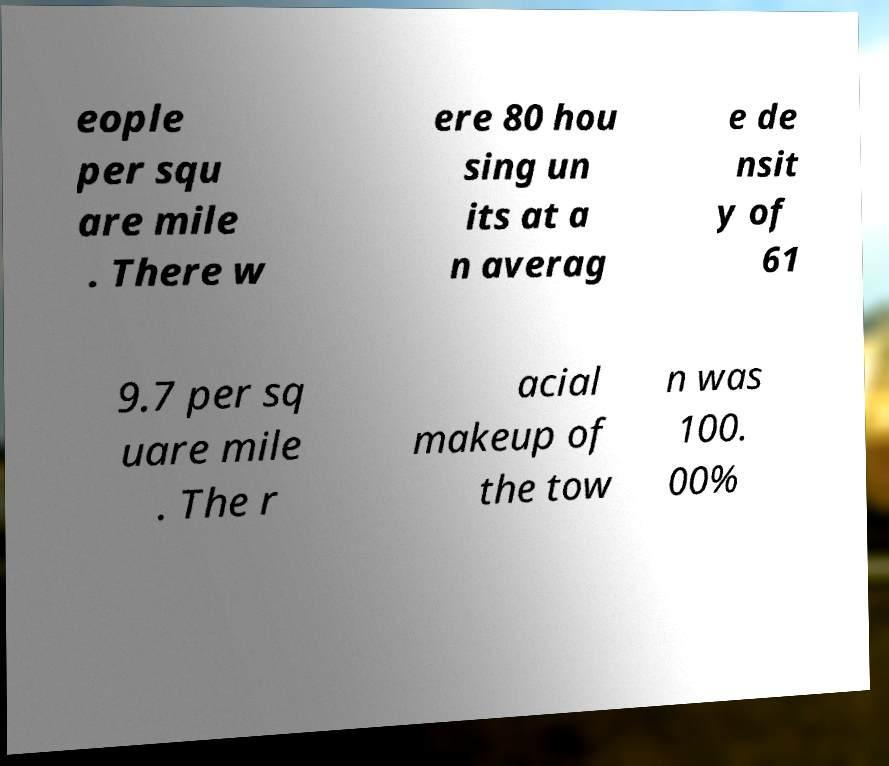For documentation purposes, I need the text within this image transcribed. Could you provide that? eople per squ are mile . There w ere 80 hou sing un its at a n averag e de nsit y of 61 9.7 per sq uare mile . The r acial makeup of the tow n was 100. 00% 